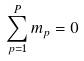Convert formula to latex. <formula><loc_0><loc_0><loc_500><loc_500>\sum _ { p = 1 } ^ { P } m _ { p } = 0</formula> 